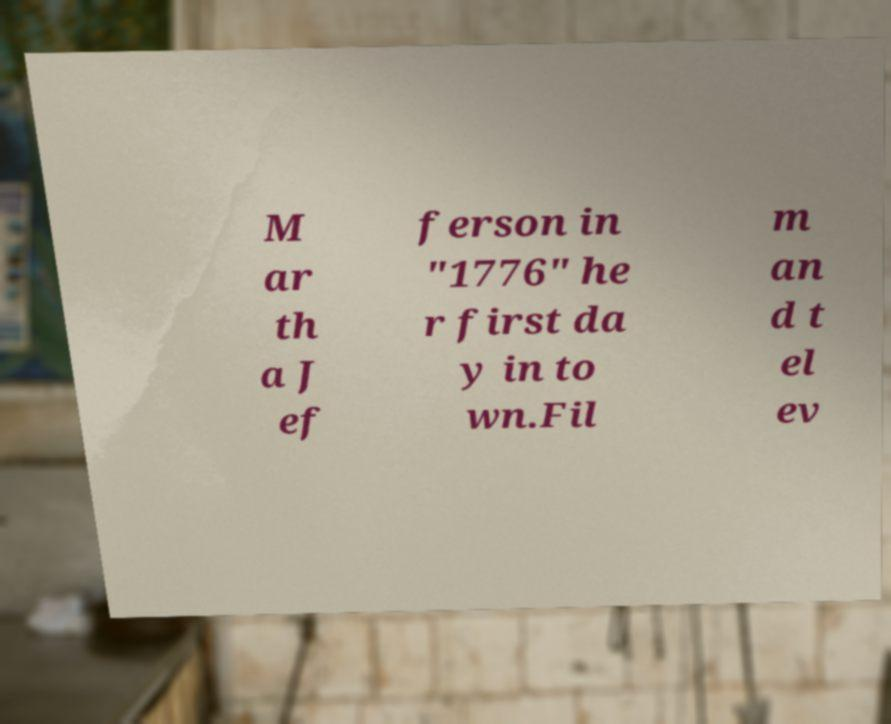Could you assist in decoding the text presented in this image and type it out clearly? M ar th a J ef ferson in "1776" he r first da y in to wn.Fil m an d t el ev 